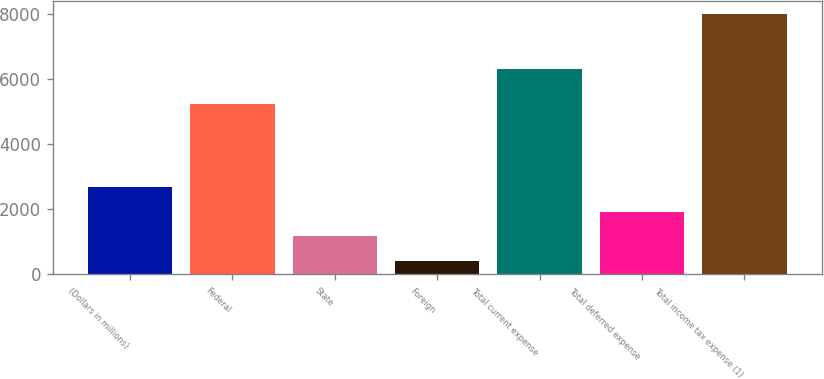Convert chart. <chart><loc_0><loc_0><loc_500><loc_500><bar_chart><fcel>(Dollars in millions)<fcel>Federal<fcel>State<fcel>Foreign<fcel>Total current expense<fcel>Total deferred expense<fcel>Total income tax expense (1)<nl><fcel>2695<fcel>5229<fcel>1175<fcel>415<fcel>6320<fcel>1935<fcel>8015<nl></chart> 